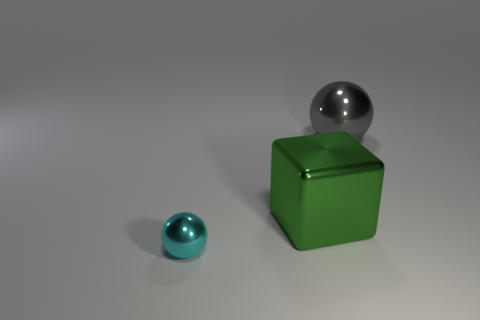How does the lighting in the image affect the appearance of the objects? The lighting creates a soft glow on the surfaces, highlighting the smooth texture of the gray sphere and bringing out the shininess of the small cyan object, while also casting subtle shadows that give depth and dimension to the scene. 